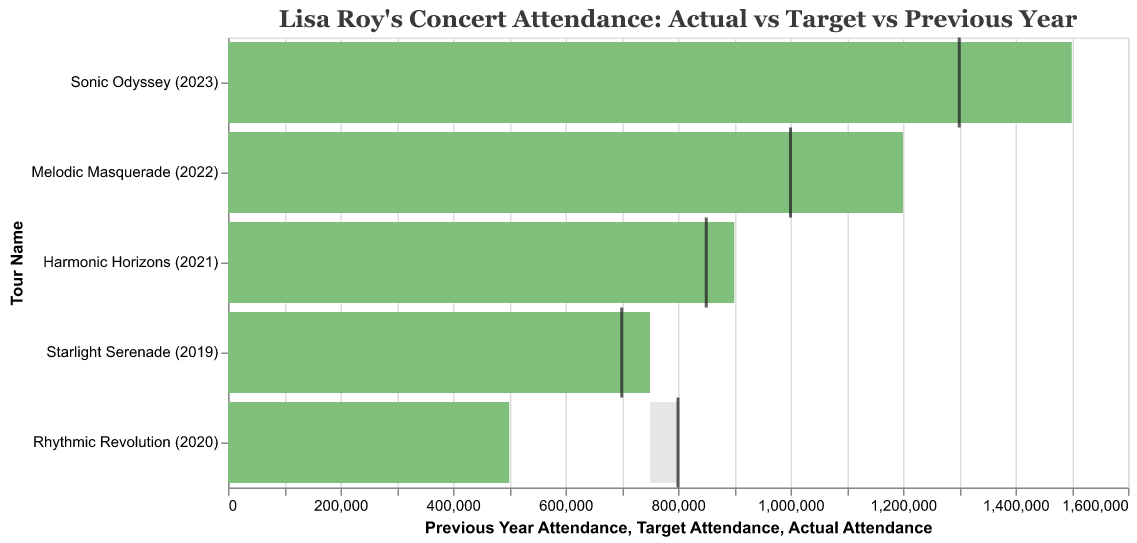What is the actual attendance for the "Harmonic Horizons" tour? The title "Harmonic Horizons (2021)" indicates the associated data. According to the bullet chart, the actual attendance is represented by the green bar. Check the value of the green bar for this tour.
Answer: 900,000 How much higher was the actual attendance compared to the target for the "Sonic Odyssey" tour? Find the values for actual and target attendance for the "Sonic Odyssey (2023)" tour. Subtract the target value from the actual value to find the difference. 1,500,000 (actual) - 1,300,000 (target) = 200,000.
Answer: 200,000 Which tour had the largest gap between actual and target attendance? Determine the differences between actual and target attendance for each tour. Compare the differences. The "Rhythmic Revolution (2020)" tour has the largest negative gap because its actual attendance (500,000) is well below the target (800,000).
Answer: "Rhythmic Revolution" Did any tour meet or exceed both target attendance and previous year attendance? Compare the actual attendance against both the target and previous year attendance for each tour. The "Starlight Serenade (2019)", "Harmonic Horizons (2021)", "Melodic Masquerade (2022)", and "Sonic Odyssey (2023)" tours meet this condition, as their actual attendances exceed both the target and previous year attendances.
Answer: Yes Which tour had the lowest actual attendance? Compare the green bars for each tour to find the smallest value. The "Rhythmic Revolution (2020)" tour has the lowest actual attendance with 500,000.
Answer: "Rhythmic Revolution" How much did the attendance increase from "Harmonic Horizons" to "Melodic Masquerade"? Subtract the actual attendance of "Harmonic Horizons (2021)" from "Melodic Masquerade (2022)". 1,200,000 (Melodic Masquerade) - 900,000 (Harmonic Horizons) = 300,000.
Answer: 300,000 Which tour year had the highest target attendance and what was the value? Look at the gray tick marks in the bullet chart to identify the highest target attendance. "Rhythmic Revolution (2020)" had the highest target attendance of 800,000.
Answer: 800,000 What percentage increase in actual attendance was there from the "Rhythmic Revolution" tour to the "Sonic Odyssey" tour? Calculate the increase in attendance and then the percentage increase: ((1,500,000 - 500,000) / 500,000) x 100 = 200%.
Answer: 200% How did the "Melodic Masquerade" tour perform relative to its target and previous year attendance? Compare the actual attendance of "Melodic Masquerade (2022)" to both its target and previous year numbers. The actual attendance (1,200,000) surpassed its target (1,000,000) and previous year attendance (900,000).
Answer: It exceeded both target and previous year attendance 